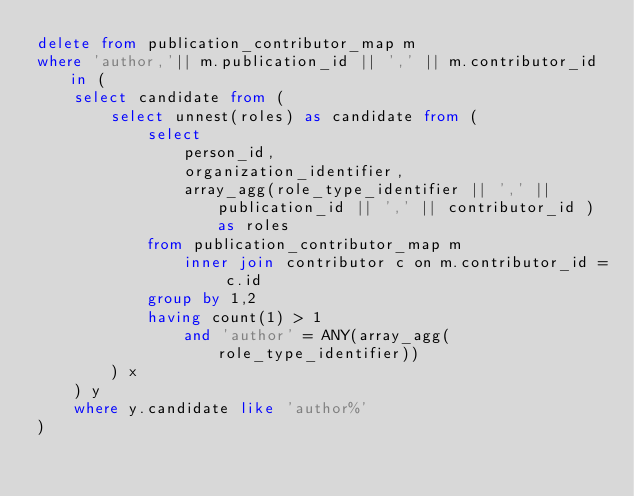Convert code to text. <code><loc_0><loc_0><loc_500><loc_500><_SQL_>delete from publication_contributor_map m
where 'author,'|| m.publication_id || ',' || m.contributor_id in (
    select candidate from (
        select unnest(roles) as candidate from (
            select 
                person_id,
                organization_identifier,
                array_agg(role_type_identifier || ',' || publication_id || ',' || contributor_id ) as roles
            from publication_contributor_map m
                inner join contributor c on m.contributor_id = c.id
            group by 1,2
            having count(1) > 1
                and 'author' = ANY(array_agg(role_type_identifier))
        ) x
    ) y
    where y.candidate like 'author%'
) 

</code> 